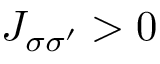<formula> <loc_0><loc_0><loc_500><loc_500>J _ { \sigma \sigma ^ { \prime } } > 0</formula> 